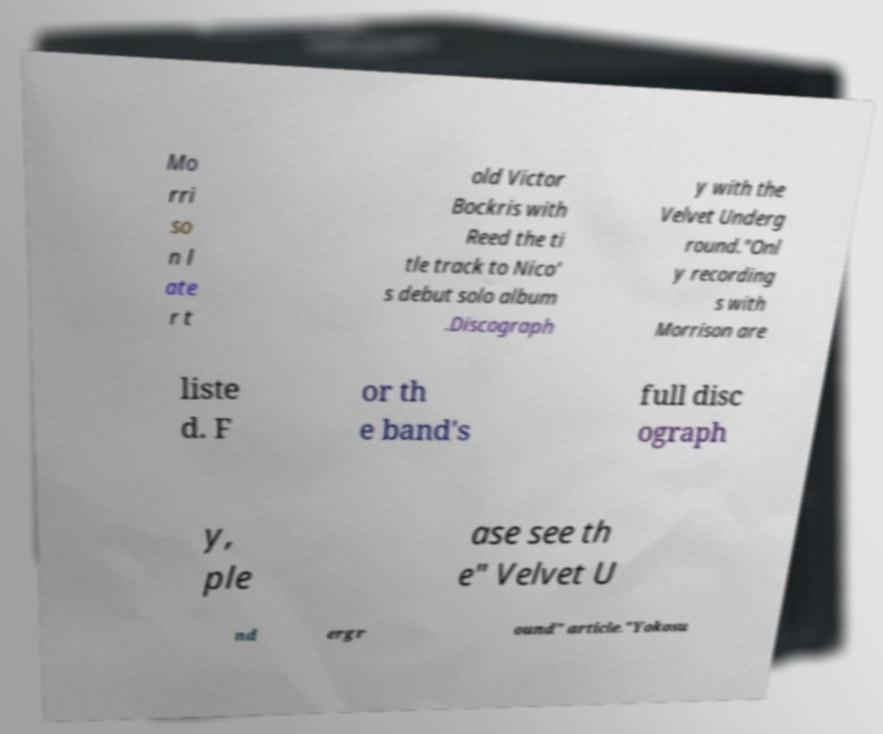Please identify and transcribe the text found in this image. Mo rri so n l ate r t old Victor Bockris with Reed the ti tle track to Nico' s debut solo album .Discograph y with the Velvet Underg round."Onl y recording s with Morrison are liste d. F or th e band's full disc ograph y, ple ase see th e" Velvet U nd ergr ound" article."Yokosu 